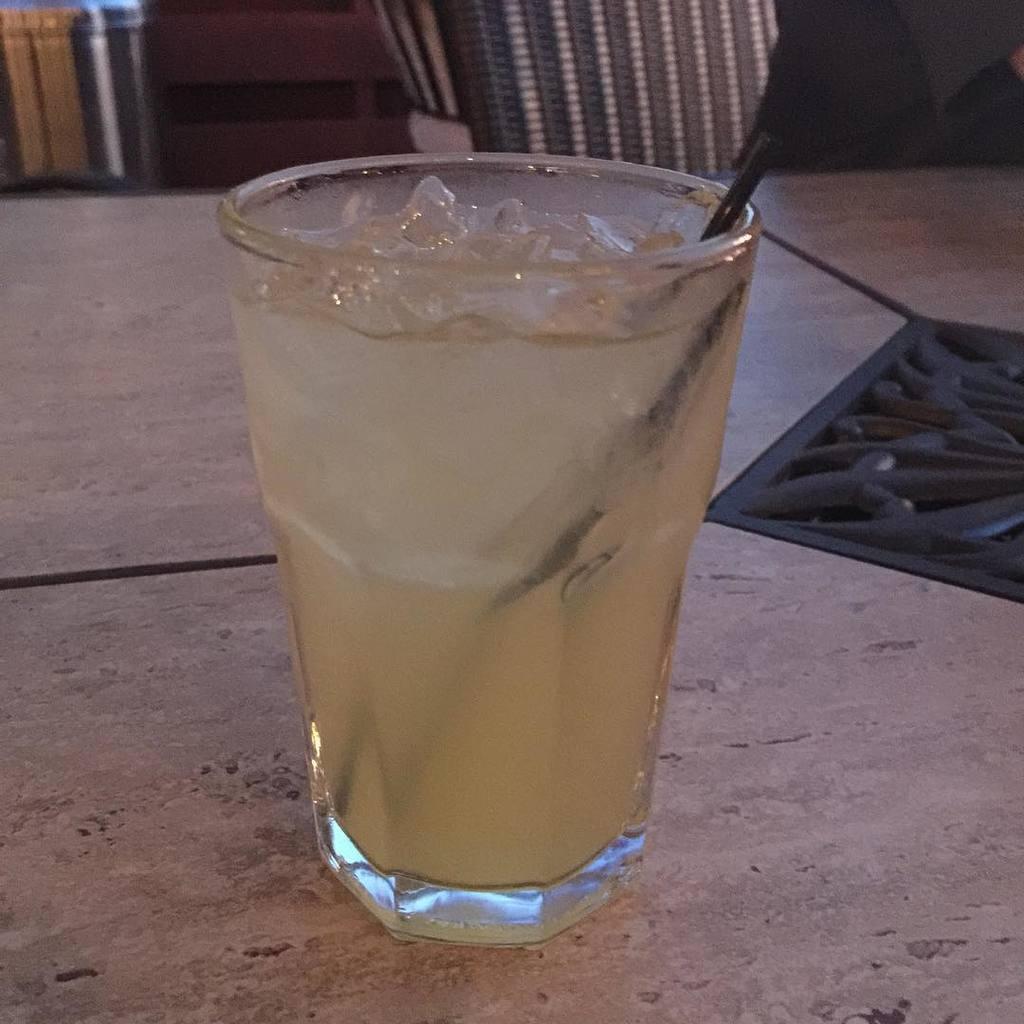Could you give a brief overview of what you see in this image? In this image there is a glass in which there is juice and there are some ice pieces at the top. There is a black colour stick inside the glass. In the background there are chairs on the right side. On the left side top there is a metal box. The glass is on the table. 